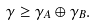Convert formula to latex. <formula><loc_0><loc_0><loc_500><loc_500>\gamma \geq \gamma _ { A } \oplus \gamma _ { B } .</formula> 